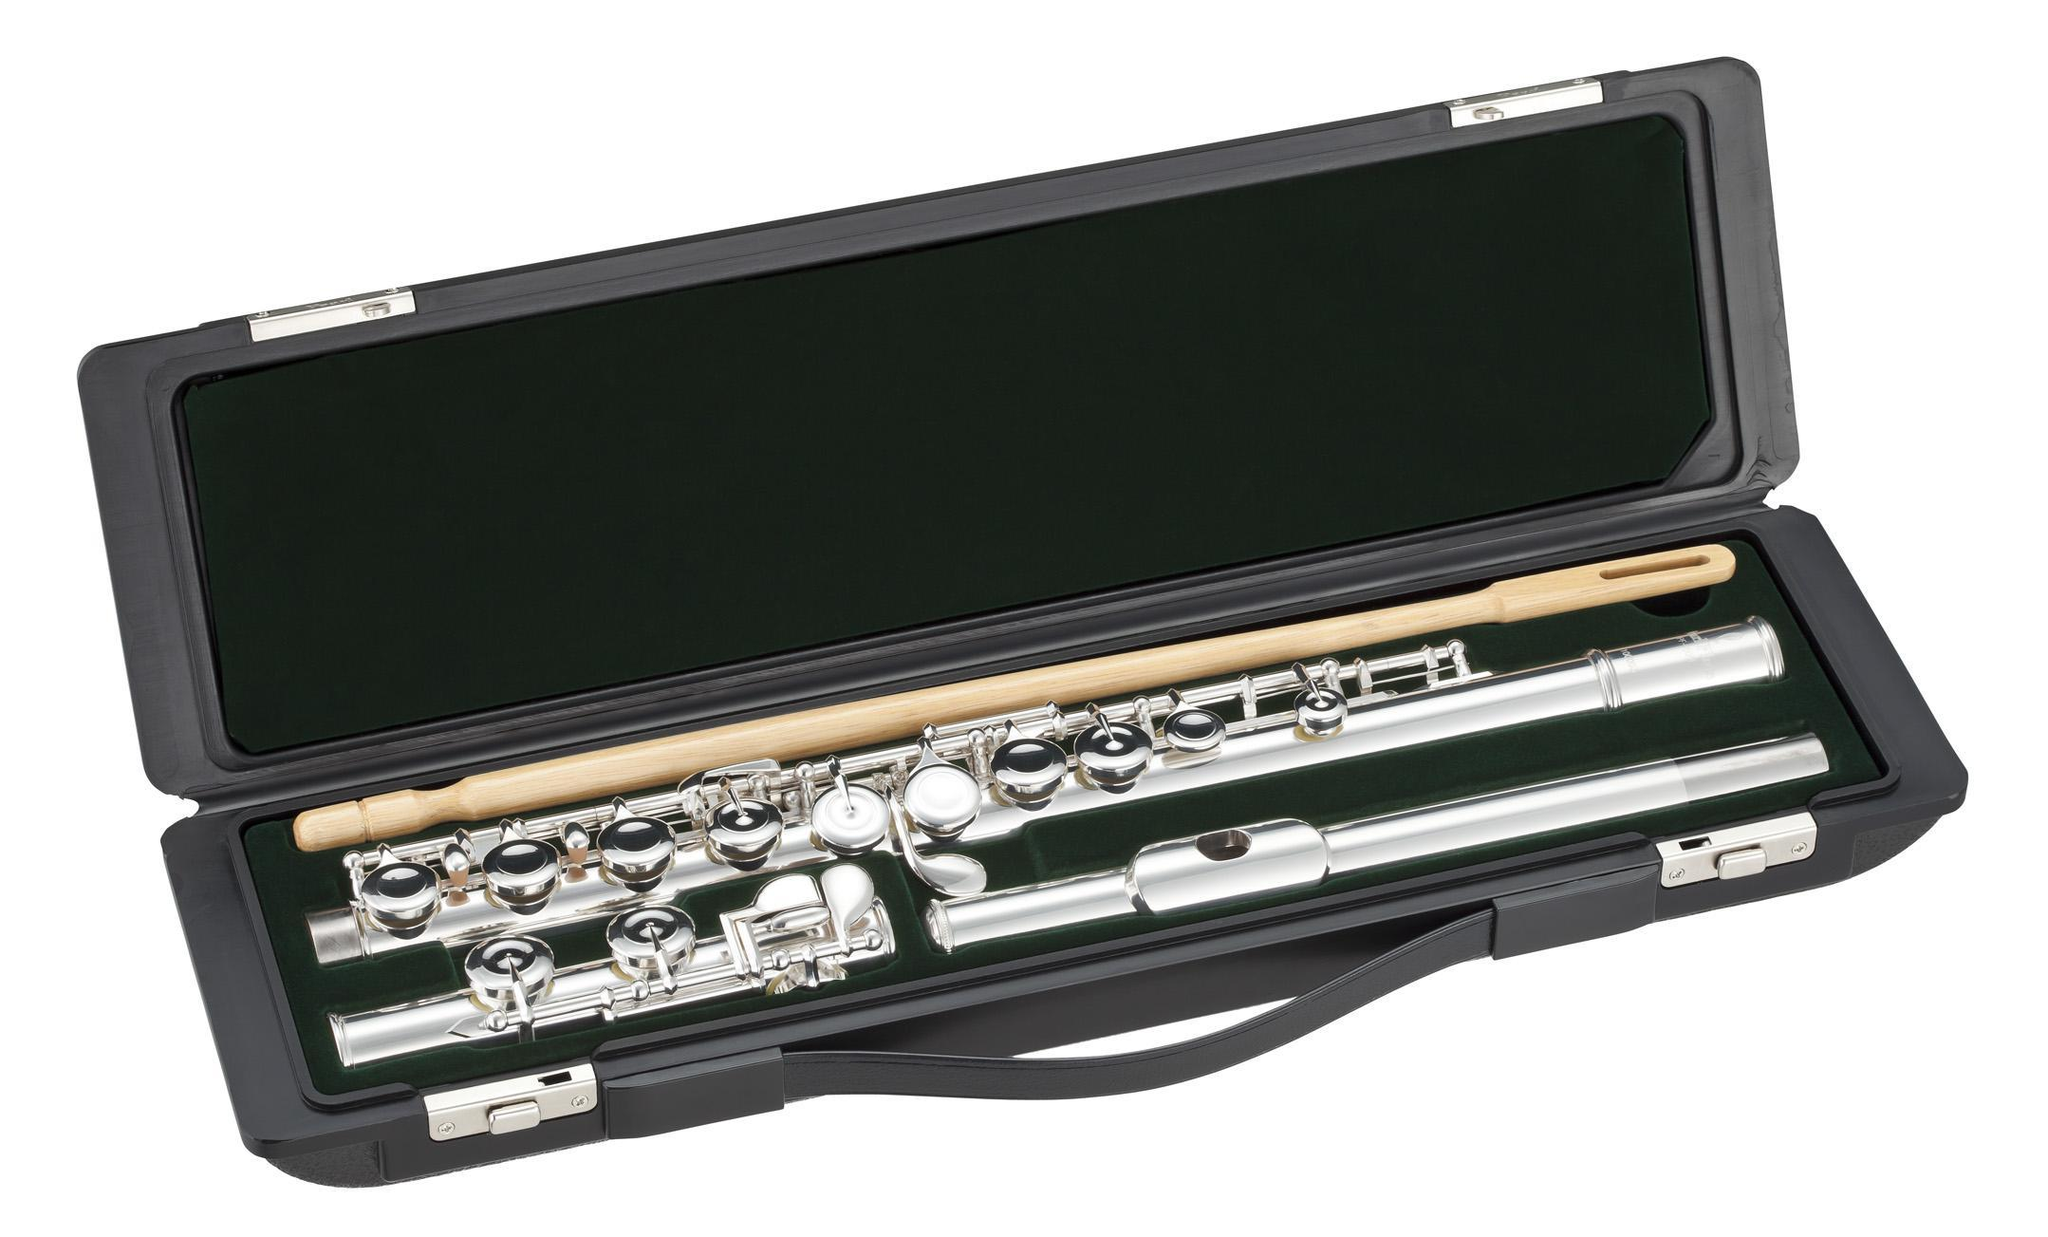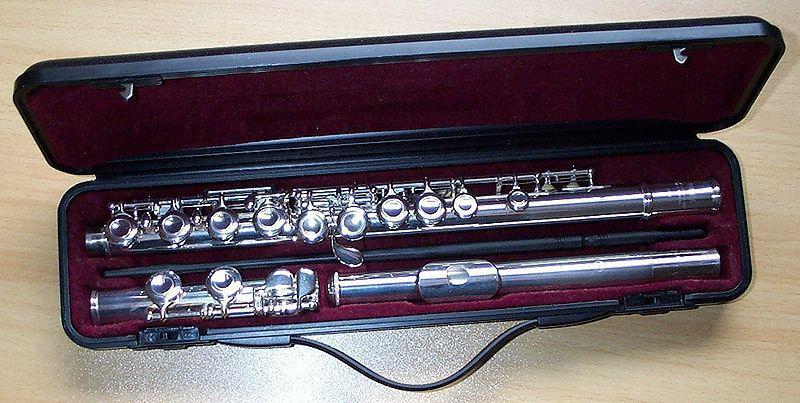The first image is the image on the left, the second image is the image on the right. For the images shown, is this caption "Each image shows instruments in or with a case." true? Answer yes or no. Yes. The first image is the image on the left, the second image is the image on the right. Considering the images on both sides, is "Each image includes an open case for an instrument, and in at least one image, an instrument is fully inside the case." valid? Answer yes or no. Yes. 